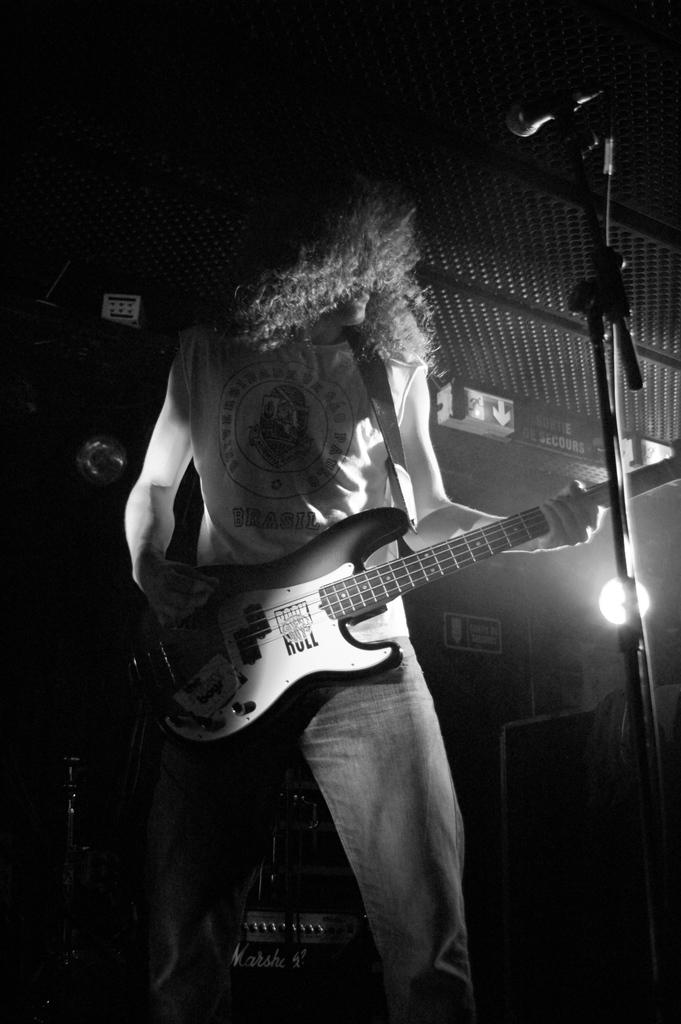What is the man in the image holding? The man is holding a guitar. What object is typically used for amplifying sound in the image? There is a microphone in the image. Can you describe any other objects present in the image? There are other objects present in the image, but their specific details are not mentioned in the provided facts. What type of bat can be seen flying in the image? There is no bat present in the image; it features a man holding a guitar and a microphone. What color is the berry that the man is holding in the image? The man is holding a guitar, not a berry, in the image. 